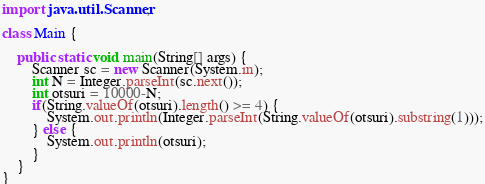<code> <loc_0><loc_0><loc_500><loc_500><_Java_>import java.util.Scanner;

class Main {

	public static void main(String[] args) {
		Scanner sc = new Scanner(System.in);
		int N = Integer.parseInt(sc.next());
		int otsuri = 10000-N;
		if(String.valueOf(otsuri).length() >= 4) {
			System.out.println(Integer.parseInt(String.valueOf(otsuri).substring(1)));
		} else {
			System.out.println(otsuri);
		}
	}
}</code> 